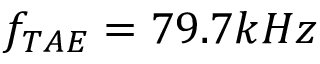<formula> <loc_0><loc_0><loc_500><loc_500>f _ { T A E } = 7 9 . 7 k H z</formula> 